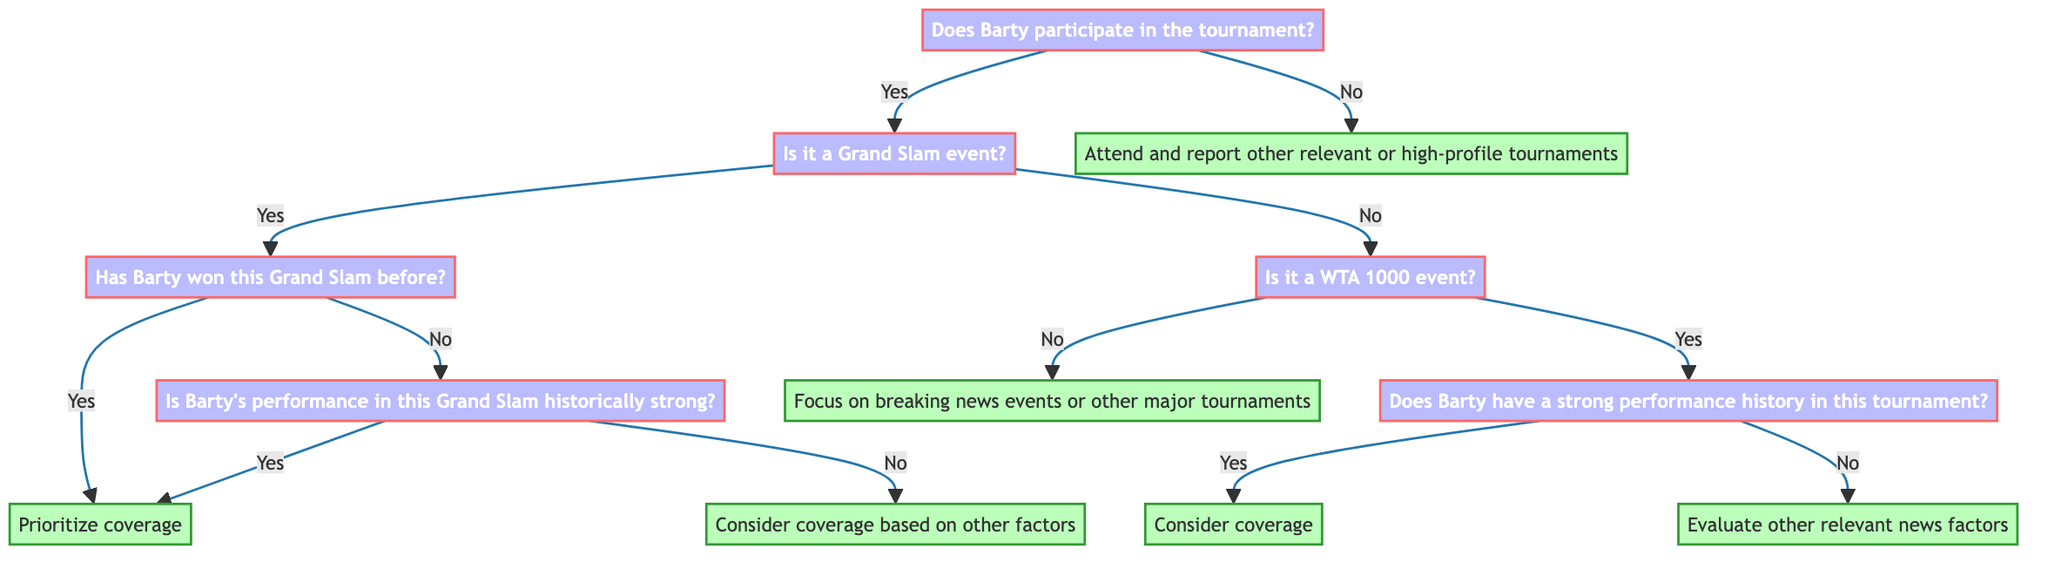Does Barty participate in the tournament? This is the initial question at the top of the decision tree. It determines the path the decision maker will follow based on Barty's participation. The answer could be "Yes" or "No"
Answer: Yes or No What is the next question if Barty participates? If the answer to Barty's participation is "Yes," the next question in the flowchart is to ask whether it is a Grand Slam event
Answer: Is it a Grand Slam event? What happens if Barty has won the Grand Slam before? If the decision maker reaches the question about whether Barty has won the Grand Slam before and the answer is "Yes," the next action indicated is to prioritize coverage of that tournament
Answer: Prioritize coverage What should be done if it is not a Grand Slam event and Barty does not participate? In the event that Barty does not participate in the tournament, the action is to attend and report on other relevant or high-profile tournaments
Answer: Attend and report other relevant or high-profile tournaments How many actions are associated with a "No" response to Barty's participation? Following the "No" response to Barty's participation, there is one direct action specified in the diagram, which leads to attending and reporting other tournaments
Answer: One action What is the outcome if Barty's performance in a Grand Slam is historically weak and she has not won it before? If the participant reaches the point where Barty's Grand Slam performance is historically weak (answer is "No") and she has not won it (answer is also "No"), the action taken is to consider coverage based on other factors
Answer: Consider coverage based on other factors What is the question following the identification of a WTA 1000 event? If the flow goes to the WTA 1000 event (after determining Barty is participating), the next question is whether Barty has a strong performance history in that specific tournament
Answer: Does Barty have a strong performance history in this tournament? What is the decision if Barty has a weak performance history in a WTA 1000 event? If the answer to Barty's performance history in a WTA 1000 event is "No," the next action specified is to evaluate other relevant news factors surrounding the tournament
Answer: Evaluate other relevant news factors 